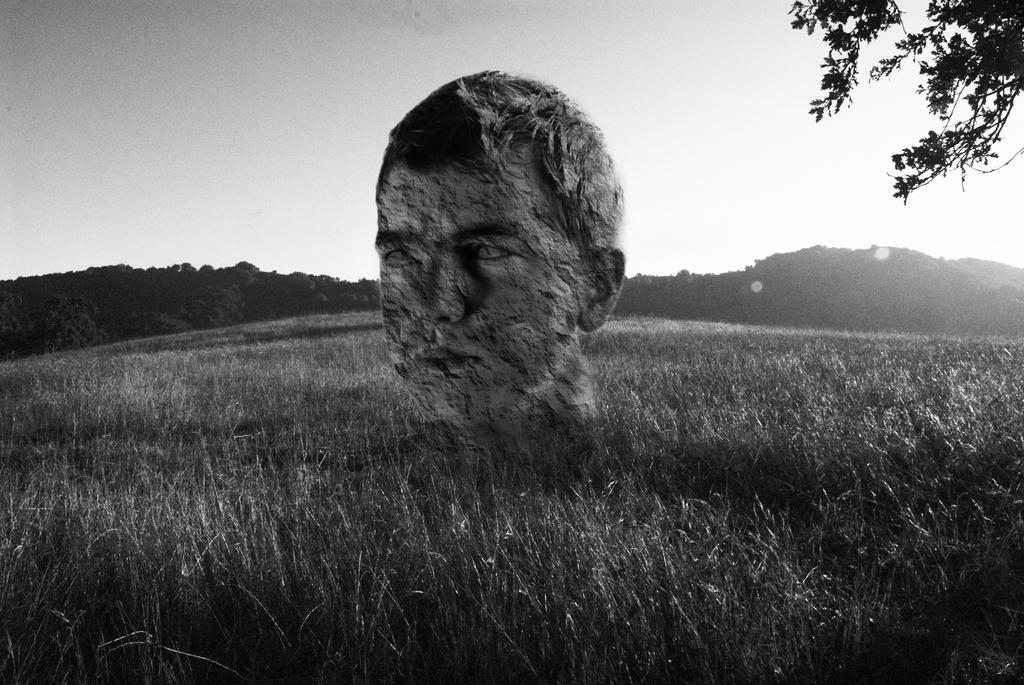What is the color scheme of the image? The image is black and white. What is the main subject of the image? There is a depiction of a person in the image. What type of terrain is visible in the image? Grass, hills, and trees are visible in the image. What part of the natural environment is visible in the image? The sky is visible in the image. What type of bulb is being used to light up the person's face in the image? There is no bulb present in the image, as it is a black and white depiction of a person in a natural environment. 